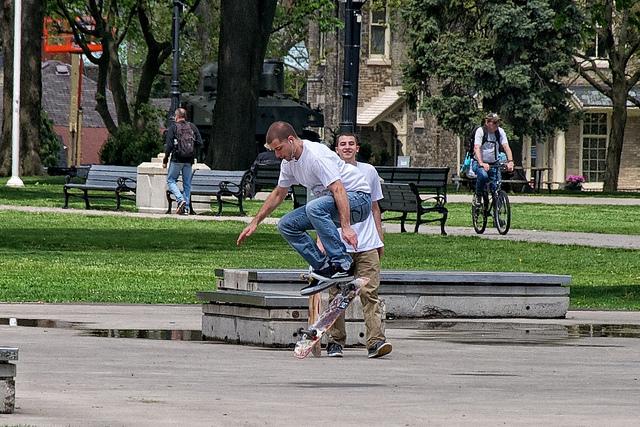Is he wearing a protective gear?
Be succinct. No. Are these kids newbies at skating?
Be succinct. No. How many benches are there?
Give a very brief answer. 5. Is the man holding him up?
Give a very brief answer. No. Where is the helmet?
Short answer required. Nowhere. What are the people riding?
Answer briefly. Skateboard. How many wheels are there?
Short answer required. 6. 